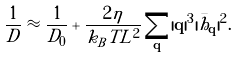<formula> <loc_0><loc_0><loc_500><loc_500>\frac { 1 } { D } \approx \frac { 1 } { D _ { 0 } } + \frac { 2 \eta } { k _ { B } T L ^ { 2 } } \sum _ { \mathbf q } | { \mathbf q } | ^ { 3 } | \bar { h } _ { \mathbf q } | ^ { 2 } .</formula> 